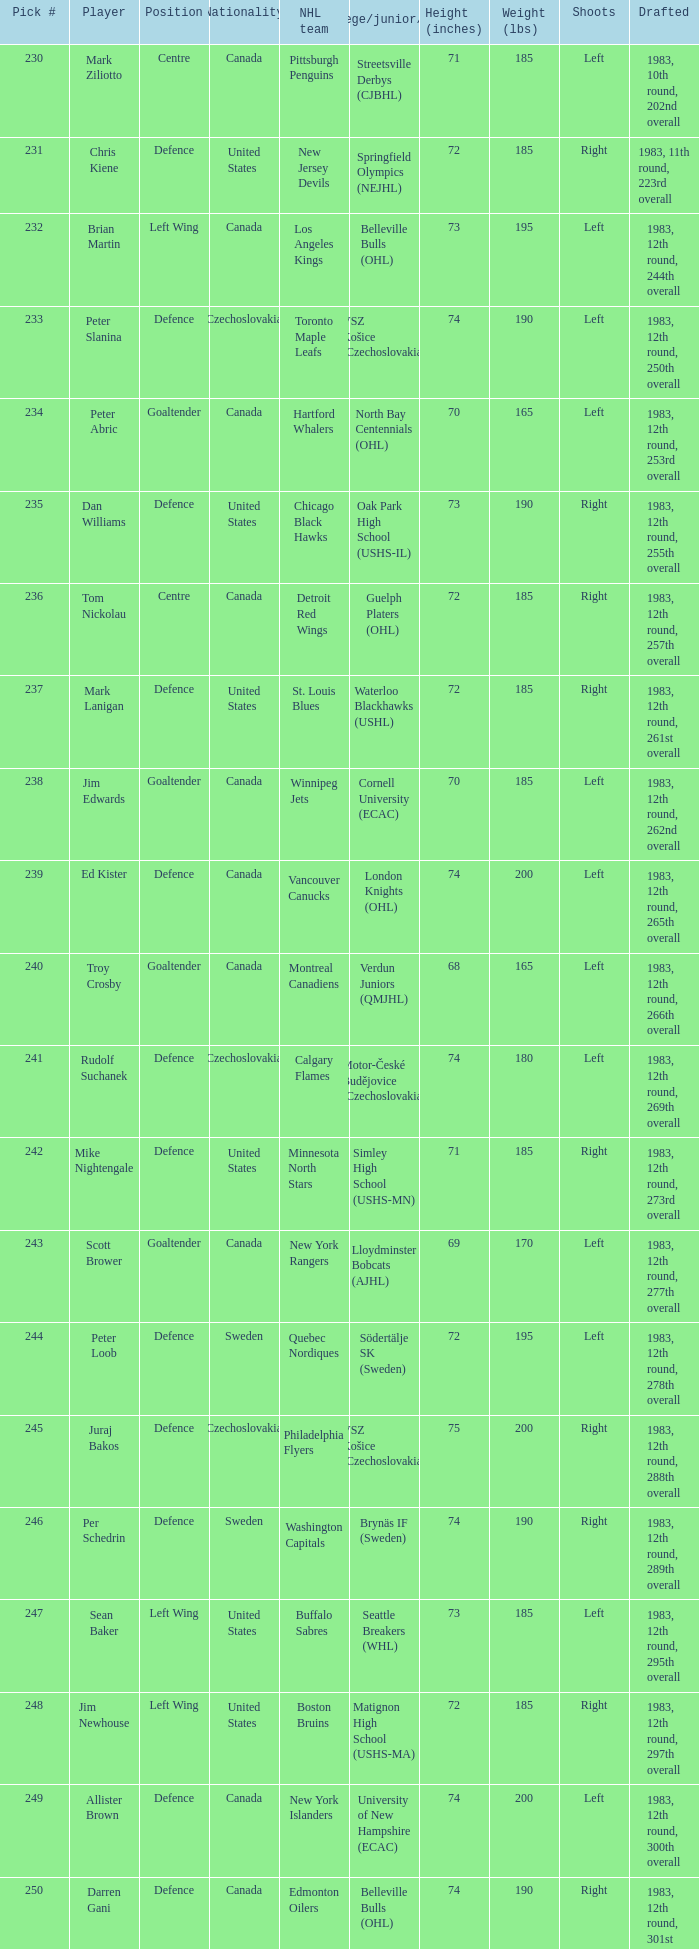List the players for team brynäs if (sweden). Per Schedrin. 